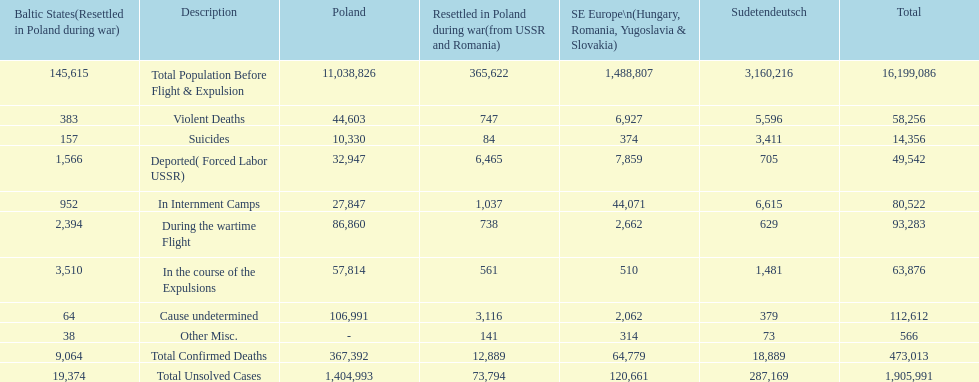What is the difference between suicides in poland and sudetendeutsch? 6919. 